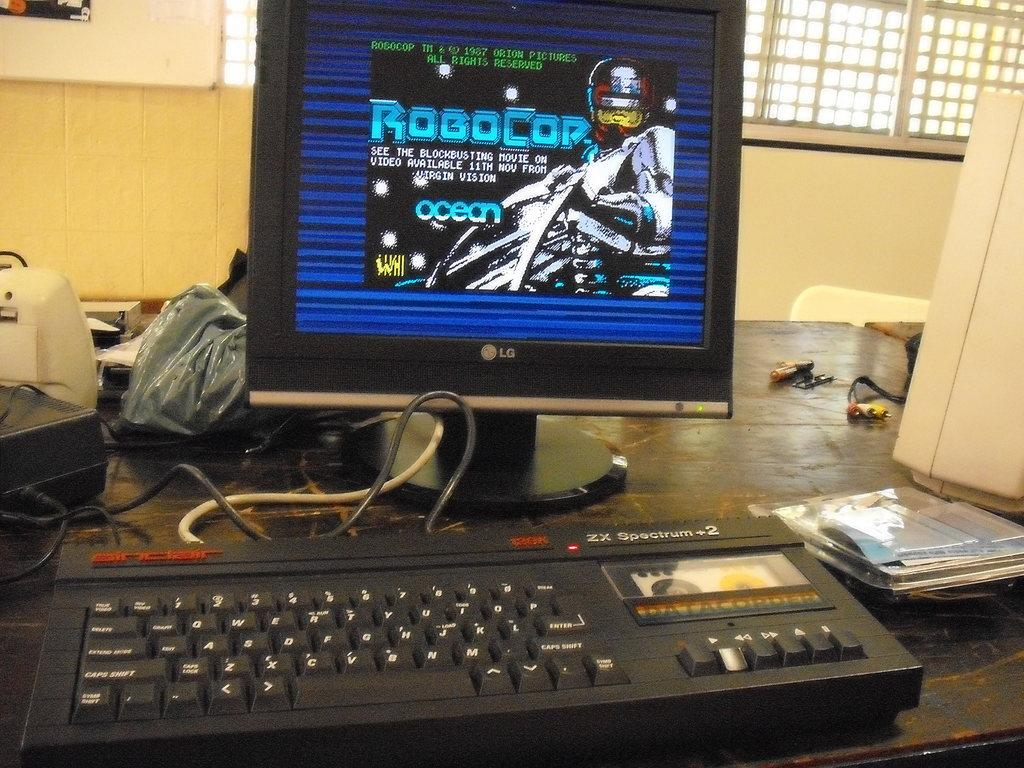<image>
Give a short and clear explanation of the subsequent image. LG computer monitor with the Robocop video game on the screen. 